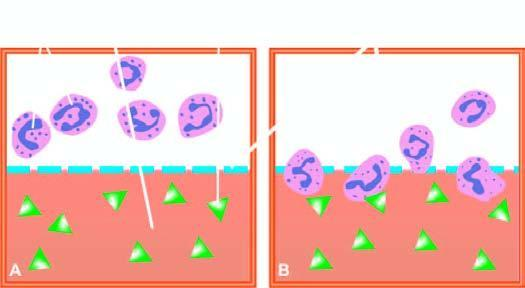re some leucocytes and red cells and a tight meshwork separated from test solution below?
Answer the question using a single word or phrase. No 